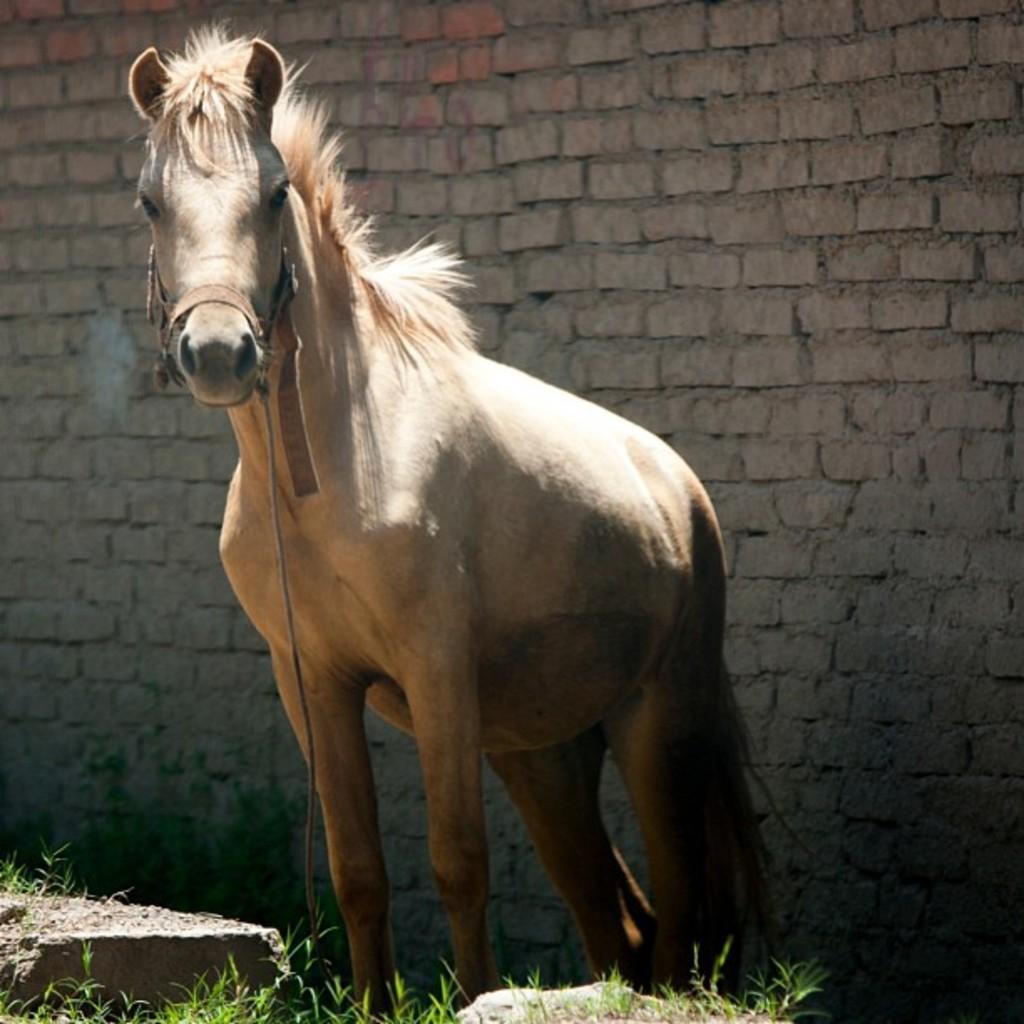Please provide a concise description of this image. In this picture I can observe a horse. In the bottom of the picture I can observe some grass on the ground. In the background there is a wall. 